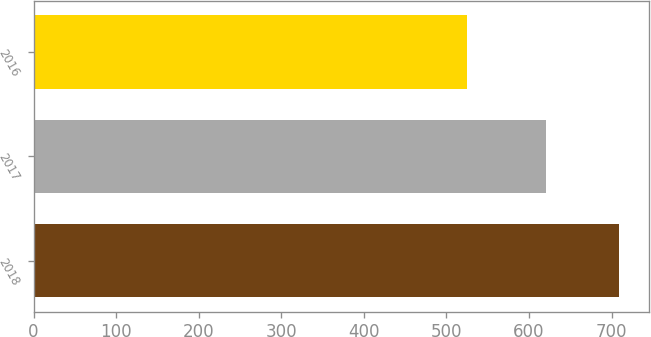<chart> <loc_0><loc_0><loc_500><loc_500><bar_chart><fcel>2018<fcel>2017<fcel>2016<nl><fcel>709.5<fcel>621.1<fcel>525.2<nl></chart> 